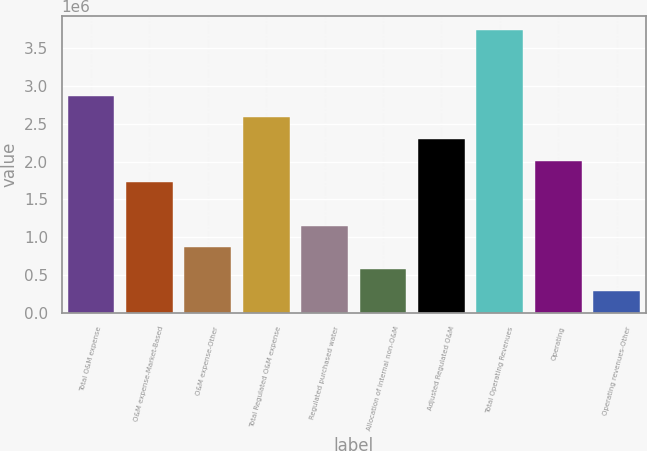<chart> <loc_0><loc_0><loc_500><loc_500><bar_chart><fcel>Total O&M expense<fcel>O&M expense-Market-Based<fcel>O&M expense-Other<fcel>Total Regulated O&M expense<fcel>Regulated purchased water<fcel>Allocation of internal non-O&M<fcel>Adjusted Regulated O&M<fcel>Total Operating Revenues<fcel>Operating<fcel>Operating revenues-Other<nl><fcel>2.87689e+06<fcel>1.72615e+06<fcel>863095<fcel>2.5892e+06<fcel>1.15078e+06<fcel>575410<fcel>2.30152e+06<fcel>3.73994e+06<fcel>2.01383e+06<fcel>287725<nl></chart> 